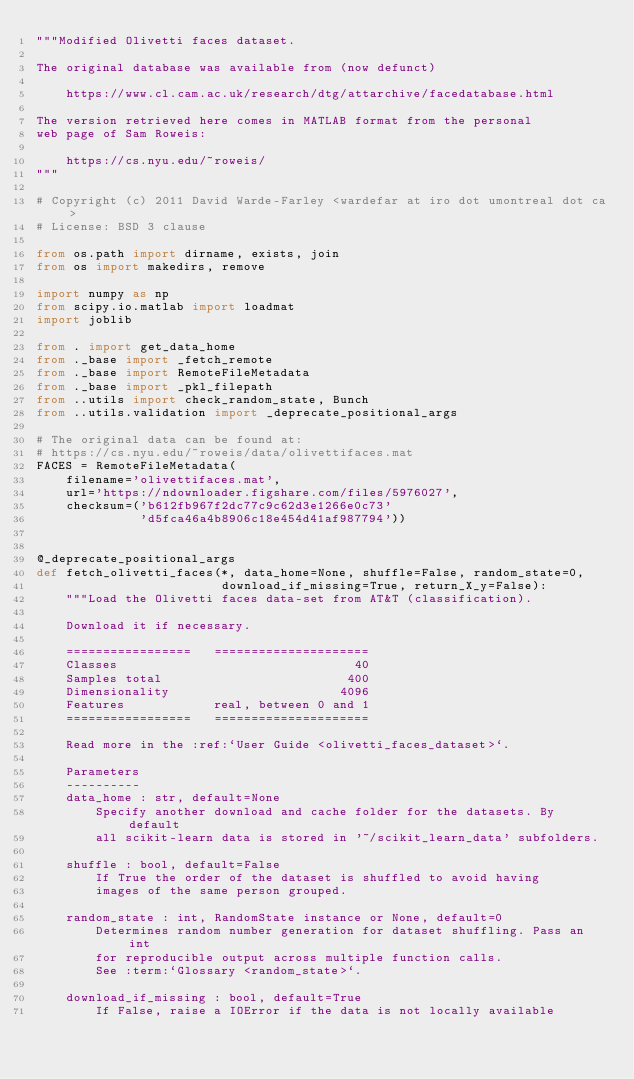<code> <loc_0><loc_0><loc_500><loc_500><_Python_>"""Modified Olivetti faces dataset.

The original database was available from (now defunct)

    https://www.cl.cam.ac.uk/research/dtg/attarchive/facedatabase.html

The version retrieved here comes in MATLAB format from the personal
web page of Sam Roweis:

    https://cs.nyu.edu/~roweis/
"""

# Copyright (c) 2011 David Warde-Farley <wardefar at iro dot umontreal dot ca>
# License: BSD 3 clause

from os.path import dirname, exists, join
from os import makedirs, remove

import numpy as np
from scipy.io.matlab import loadmat
import joblib

from . import get_data_home
from ._base import _fetch_remote
from ._base import RemoteFileMetadata
from ._base import _pkl_filepath
from ..utils import check_random_state, Bunch
from ..utils.validation import _deprecate_positional_args

# The original data can be found at:
# https://cs.nyu.edu/~roweis/data/olivettifaces.mat
FACES = RemoteFileMetadata(
    filename='olivettifaces.mat',
    url='https://ndownloader.figshare.com/files/5976027',
    checksum=('b612fb967f2dc77c9c62d3e1266e0c73'
              'd5fca46a4b8906c18e454d41af987794'))


@_deprecate_positional_args
def fetch_olivetti_faces(*, data_home=None, shuffle=False, random_state=0,
                         download_if_missing=True, return_X_y=False):
    """Load the Olivetti faces data-set from AT&T (classification).

    Download it if necessary.

    =================   =====================
    Classes                                40
    Samples total                         400
    Dimensionality                       4096
    Features            real, between 0 and 1
    =================   =====================

    Read more in the :ref:`User Guide <olivetti_faces_dataset>`.

    Parameters
    ----------
    data_home : str, default=None
        Specify another download and cache folder for the datasets. By default
        all scikit-learn data is stored in '~/scikit_learn_data' subfolders.

    shuffle : bool, default=False
        If True the order of the dataset is shuffled to avoid having
        images of the same person grouped.

    random_state : int, RandomState instance or None, default=0
        Determines random number generation for dataset shuffling. Pass an int
        for reproducible output across multiple function calls.
        See :term:`Glossary <random_state>`.

    download_if_missing : bool, default=True
        If False, raise a IOError if the data is not locally available</code> 